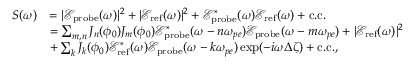Convert formula to latex. <formula><loc_0><loc_0><loc_500><loc_500>\begin{array} { r l } { S ( \omega ) } & { = | \mathcal { E } _ { p r o b e } ( \omega ) | ^ { 2 } + | \mathcal { E } _ { r e f } ( \omega ) | ^ { 2 } + \mathcal { E } _ { p r o b e } ^ { * } ( \omega ) \mathcal { E } _ { r e f } ( \omega ) + c . c . } \\ & { = \sum _ { m , n } J _ { n } ( \phi _ { 0 } ) J _ { m } ( \phi _ { 0 } ) \mathcal { E } _ { p r o b e } ^ { * } ( \omega - n \omega _ { p e } ) \mathcal { E } _ { p r o b e } ( \omega - m \omega _ { p e } ) + | \mathcal { E } _ { r e f } ( \omega ) | ^ { 2 } } \\ & { + \sum _ { k } J _ { k } ( \phi _ { 0 } ) \mathcal { E } _ { r e f } ^ { * } ( \omega ) \mathcal { E } _ { p r o b e } ( \omega - k \omega _ { p e } ) \exp ( - i \omega \Delta \zeta ) + c . c . , } \end{array}</formula> 